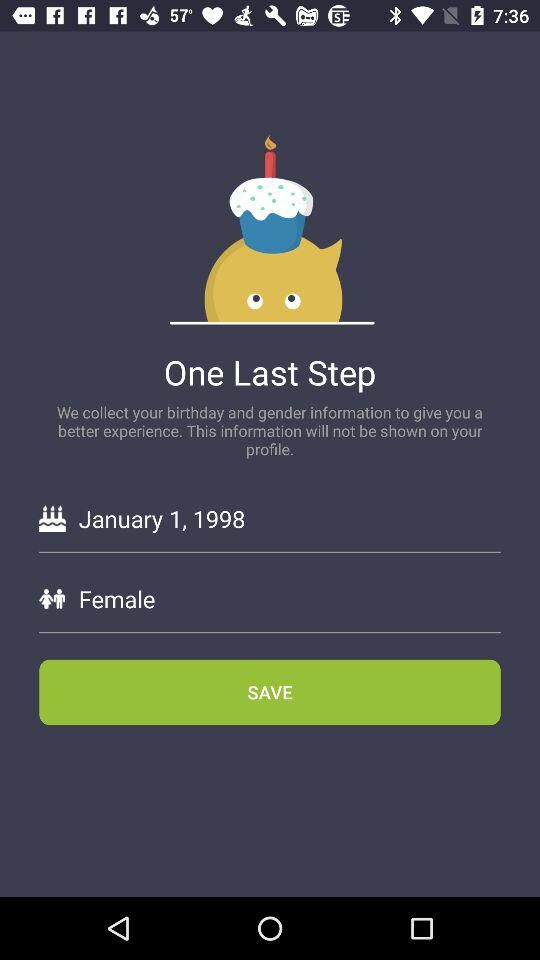What is the date of birth? The date of birth is January 1, 1998. 